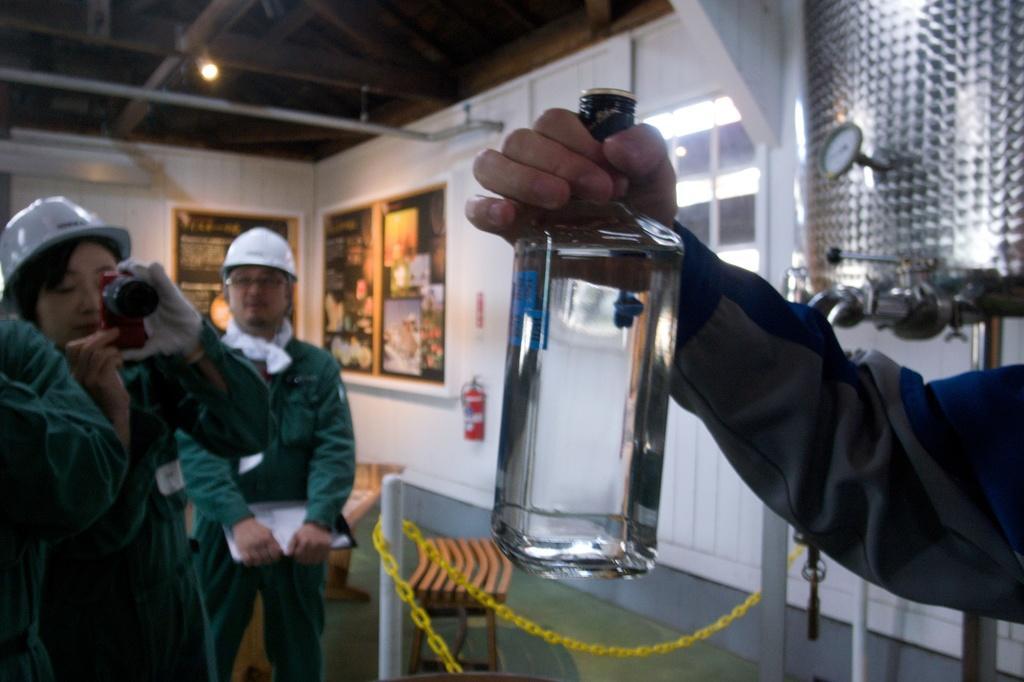Can you describe this image briefly? In this image I can see three people. I can see two people with helmets. I can see one person is holding the camera, on another person holding the glass bottle and another person with some white color object. In the background I can see the fire extinguisher and the boards to the wall. I can see the light in the top. 